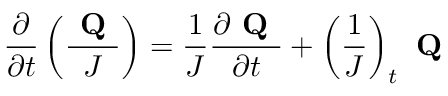<formula> <loc_0><loc_0><loc_500><loc_500>\frac { \partial } { \partial t } \left ( \frac { Q } { J } \right ) = \frac { 1 } { J } \frac { \partial Q } { \partial t } + \left ( \frac { 1 } { J } \right ) _ { t } Q</formula> 